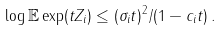<formula> <loc_0><loc_0><loc_500><loc_500>\log \mathbb { E } \exp ( t Z _ { i } ) \leq ( \sigma _ { i } t ) ^ { 2 } / ( 1 - c _ { i } t ) \, .</formula> 